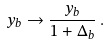Convert formula to latex. <formula><loc_0><loc_0><loc_500><loc_500>y _ { b } \to \frac { y _ { b } } { 1 + \Delta _ { b } } \, .</formula> 